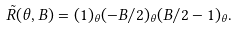Convert formula to latex. <formula><loc_0><loc_0><loc_500><loc_500>\tilde { R } ( \theta , B ) = ( 1 ) _ { \theta } ( - B / 2 ) _ { \theta } ( B / 2 - 1 ) _ { \theta } .</formula> 